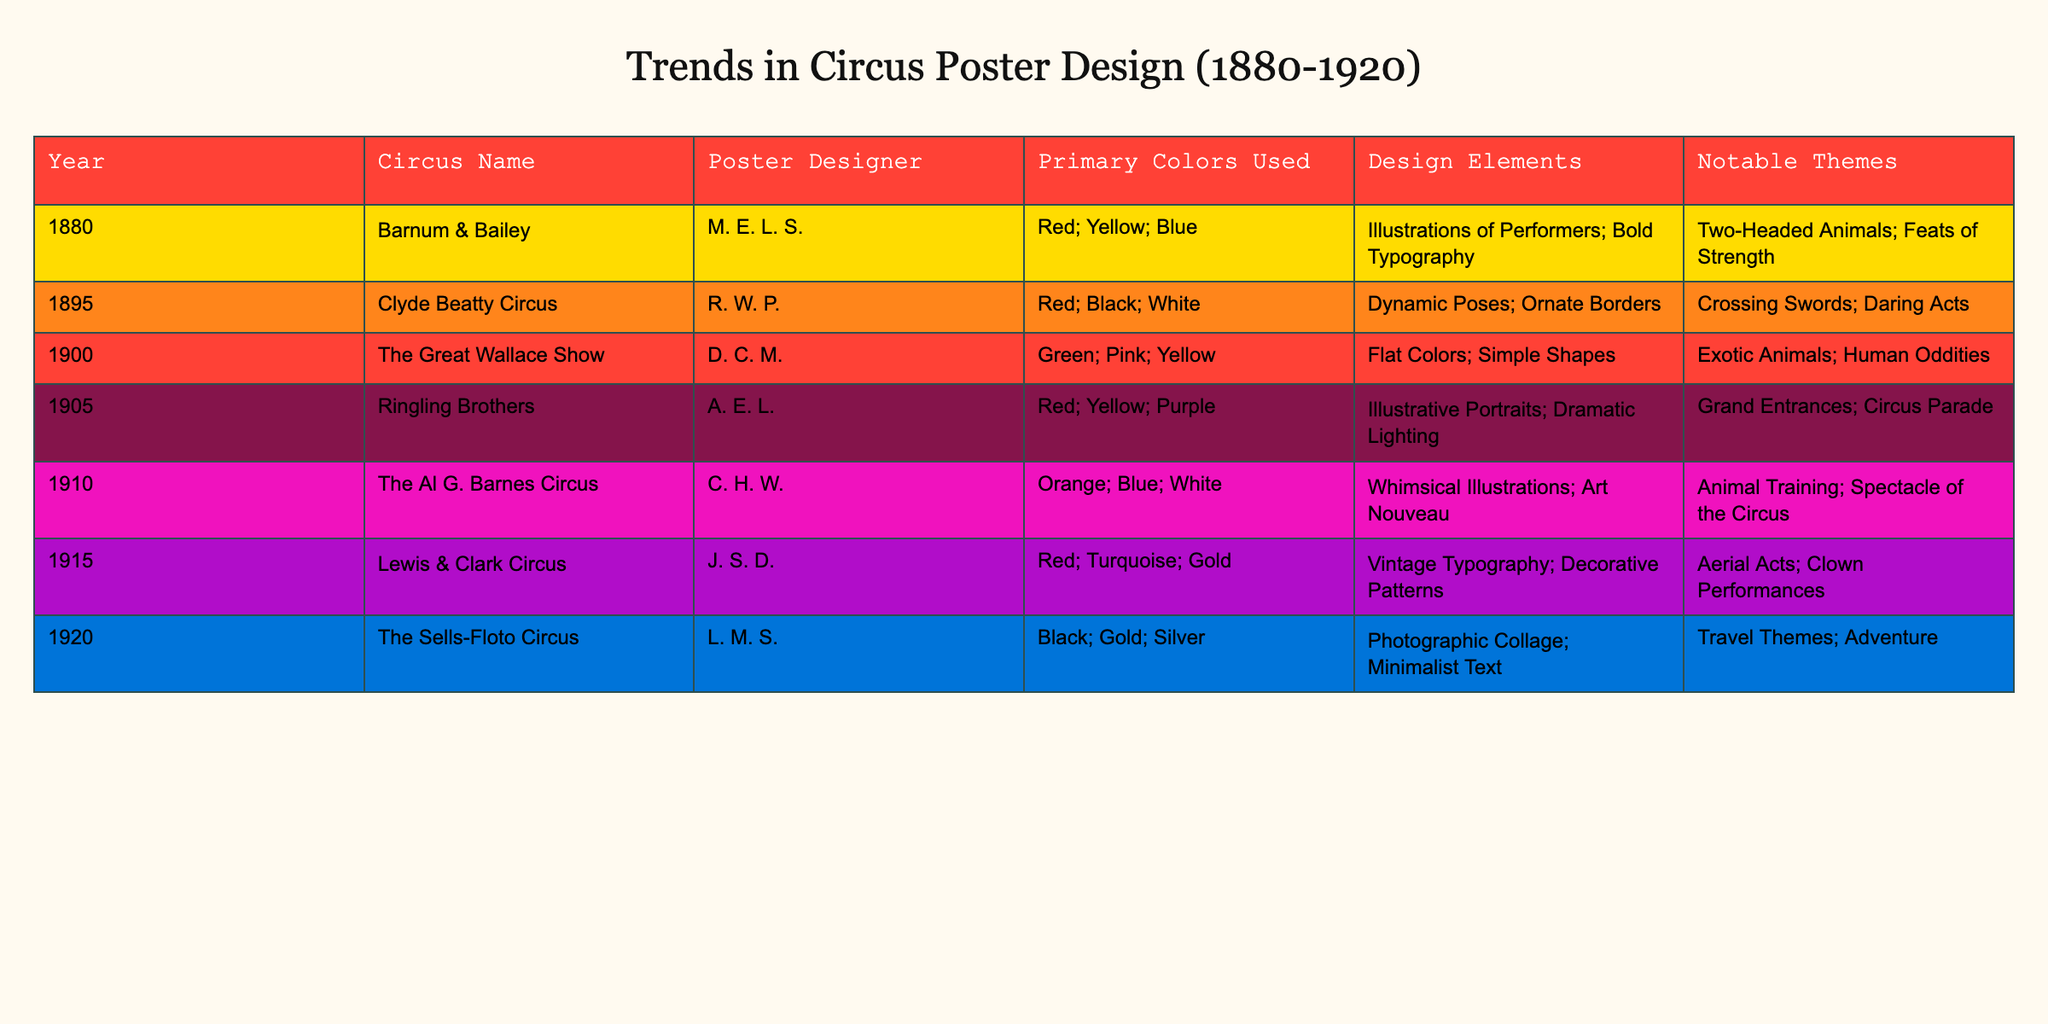What was the primary color used by Barnum & Bailey in 1880? The table shows that Barnum & Bailey used the primary colors Red, Yellow, and Blue in 1880. Looking at the column specifically for Primary Colors Used, we can see these colors listed for that circus.
Answer: Red; Yellow; Blue Which circus had the notable theme of "Animal Training"? By checking the Notable Themes column, we see that The Al G. Barnes Circus, which performed in 1910, is associated with the theme of Animal Training.
Answer: The Al G. Barnes Circus In which year did the use of Black as a primary color first appear? Inspecting the Primary Colors Used column, Black appears for the first time in 1920 with The Sells-Floto Circus. Before that year, none of the listed circuses used Black as a primary color.
Answer: 1920 What are the two most common primary colors used across all the posters? By examining the Primary Colors Used column, Red appears for Barnum & Bailey, Clyde Beatty Circus, Ringling Brothers, and Lewis & Clark Circus, while Yellow is also prevalent in multiple posters. Counting these occurrences, we find they are the most common.
Answer: Red; Yellow Was there any circus poster designed by a female designer? The table lists the Circus Name and Poster Designer columns. Based on the data, all listed designers are male, meaning there are no female designers noted among the posters presented.
Answer: No What notable themes were presented in the posters of Lewis & Clark Circus and The Sells-Floto Circus? Looking at the Notable Themes for Lewis & Clark Circus (1915), we have Aerial Acts and Clown Performances, while for The Sells-Floto Circus (1920), the notable themes were Travel Themes and Adventure. Both provide insights into the unique aspects celebrated in each circus.
Answer: Aerial Acts; Clown Performances; Travel Themes; Adventure Which year saw the introduction of Art Nouveau design elements in circus posters? Observing the Design Elements column, the year 1910 with The Al G. Barnes Circus is noted for Whimsical Illustrations and the Art Nouveau style. This indicates that 1910 is when this design trend was introduced in circus posters.
Answer: 1910 How many different primary colors were used by The Great Wallace Show? In the data, The Great Wallace Show used Green, Pink, and Yellow as its primary colors. Counting these, there are three distinct primary colors listed for this show.
Answer: 3 What is the average number of notable themes per circus based on the table? Each circus listed has one notable theme according to the data provided. Since there are seven circuses, dividing the total number of themes (7) by the number of circuses (7) gives an average of 1 theme per circus.
Answer: 1 